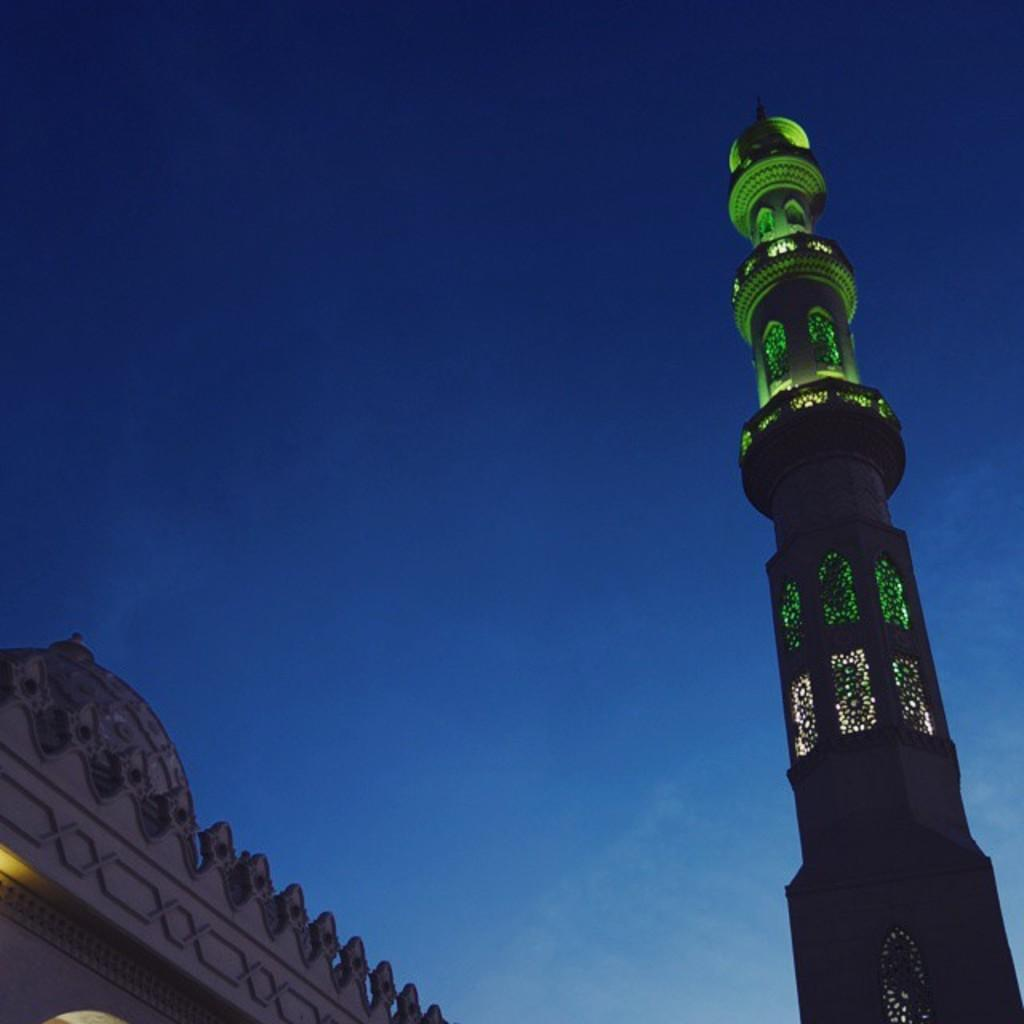What type of building is in the picture? There is a mosque in the picture. What specific feature of the mosque is highlighted in the picture? There is a minaret with a green light focus in the picture. What can be seen in the background of the picture? The sky is visible in the background of the picture. What is the color of the sky in the picture? The sky is blue in color. How does the mosque help beginners learn balance in the image? The image does not show the mosque helping beginners learn balance, as it is a religious building and not a training facility. 